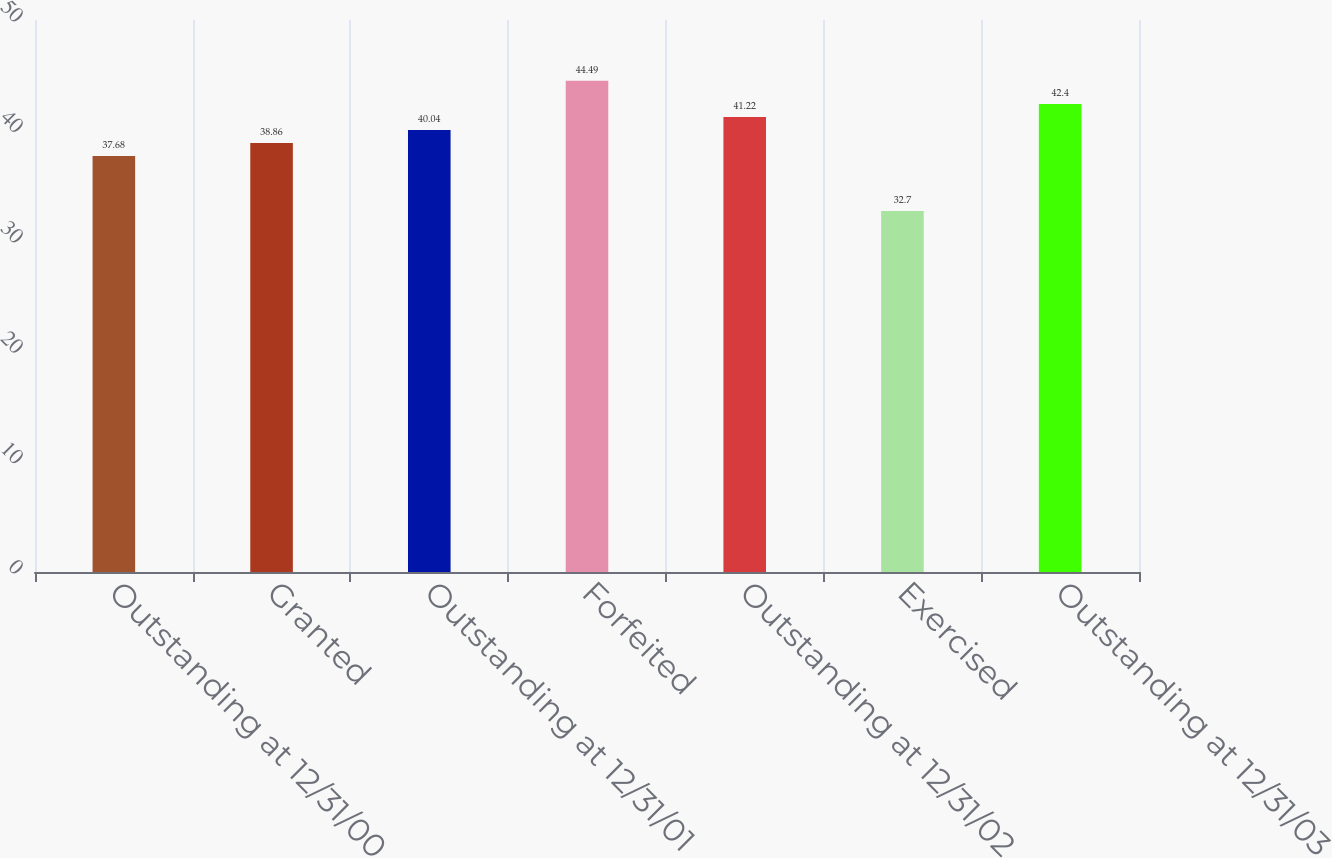Convert chart to OTSL. <chart><loc_0><loc_0><loc_500><loc_500><bar_chart><fcel>Outstanding at 12/31/00<fcel>Granted<fcel>Outstanding at 12/31/01<fcel>Forfeited<fcel>Outstanding at 12/31/02<fcel>Exercised<fcel>Outstanding at 12/31/03<nl><fcel>37.68<fcel>38.86<fcel>40.04<fcel>44.49<fcel>41.22<fcel>32.7<fcel>42.4<nl></chart> 